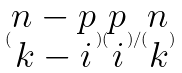<formula> <loc_0><loc_0><loc_500><loc_500>( \begin{matrix} n - p \\ k - i \end{matrix} ) ( \begin{matrix} p \\ i \end{matrix} ) / ( \begin{matrix} n \\ k \end{matrix} )</formula> 